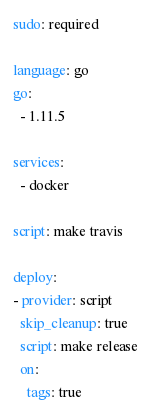<code> <loc_0><loc_0><loc_500><loc_500><_YAML_>sudo: required

language: go
go:
  - 1.11.5

services:
  - docker

script: make travis

deploy:
- provider: script
  skip_cleanup: true
  script: make release
  on:
    tags: true
</code> 